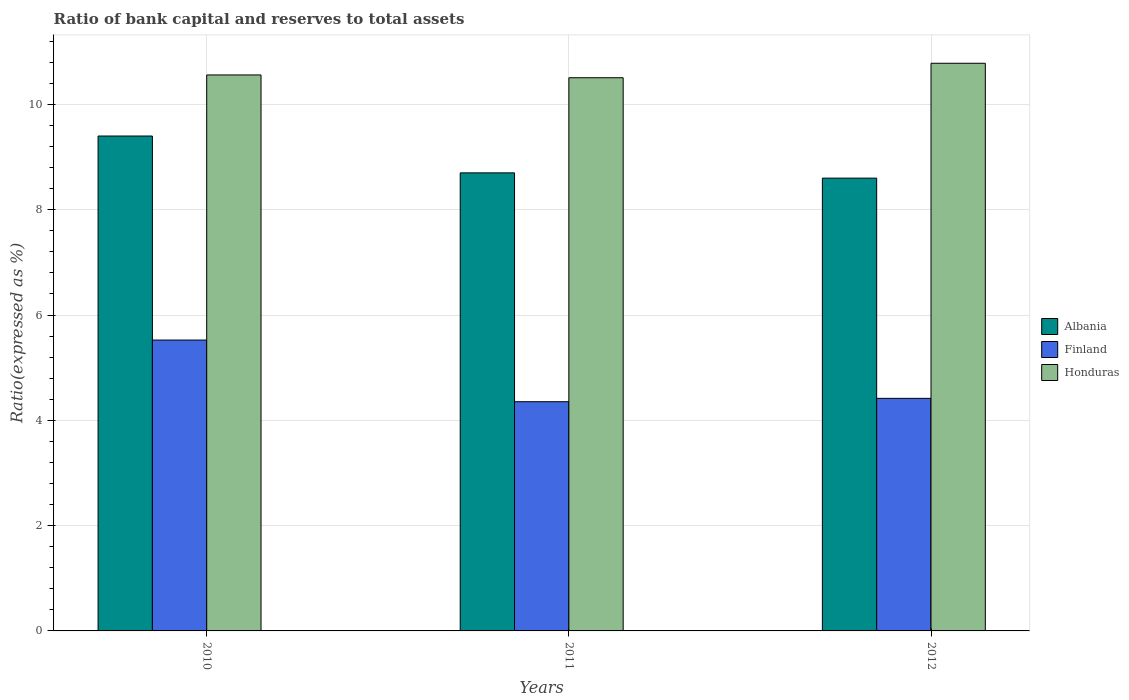How many different coloured bars are there?
Give a very brief answer. 3. How many groups of bars are there?
Give a very brief answer. 3. Are the number of bars per tick equal to the number of legend labels?
Offer a very short reply. Yes. How many bars are there on the 2nd tick from the left?
Provide a succinct answer. 3. How many bars are there on the 1st tick from the right?
Your answer should be very brief. 3. What is the label of the 3rd group of bars from the left?
Your answer should be very brief. 2012. In how many cases, is the number of bars for a given year not equal to the number of legend labels?
Offer a terse response. 0. What is the ratio of bank capital and reserves to total assets in Honduras in 2011?
Offer a very short reply. 10.51. Across all years, what is the maximum ratio of bank capital and reserves to total assets in Honduras?
Ensure brevity in your answer.  10.78. Across all years, what is the minimum ratio of bank capital and reserves to total assets in Albania?
Your answer should be compact. 8.6. In which year was the ratio of bank capital and reserves to total assets in Honduras maximum?
Give a very brief answer. 2012. In which year was the ratio of bank capital and reserves to total assets in Honduras minimum?
Your answer should be compact. 2011. What is the total ratio of bank capital and reserves to total assets in Albania in the graph?
Keep it short and to the point. 26.7. What is the difference between the ratio of bank capital and reserves to total assets in Honduras in 2011 and that in 2012?
Your answer should be very brief. -0.28. What is the difference between the ratio of bank capital and reserves to total assets in Finland in 2010 and the ratio of bank capital and reserves to total assets in Honduras in 2012?
Keep it short and to the point. -5.26. What is the average ratio of bank capital and reserves to total assets in Finland per year?
Keep it short and to the point. 4.77. In the year 2010, what is the difference between the ratio of bank capital and reserves to total assets in Finland and ratio of bank capital and reserves to total assets in Albania?
Your response must be concise. -3.88. In how many years, is the ratio of bank capital and reserves to total assets in Albania greater than 3.6 %?
Your answer should be compact. 3. What is the ratio of the ratio of bank capital and reserves to total assets in Honduras in 2011 to that in 2012?
Give a very brief answer. 0.97. What is the difference between the highest and the second highest ratio of bank capital and reserves to total assets in Albania?
Your answer should be compact. 0.7. What is the difference between the highest and the lowest ratio of bank capital and reserves to total assets in Albania?
Provide a succinct answer. 0.8. In how many years, is the ratio of bank capital and reserves to total assets in Honduras greater than the average ratio of bank capital and reserves to total assets in Honduras taken over all years?
Your answer should be compact. 1. What does the 3rd bar from the left in 2011 represents?
Ensure brevity in your answer.  Honduras. What does the 1st bar from the right in 2011 represents?
Keep it short and to the point. Honduras. How many bars are there?
Provide a succinct answer. 9. What is the difference between two consecutive major ticks on the Y-axis?
Offer a terse response. 2. Does the graph contain any zero values?
Make the answer very short. No. Does the graph contain grids?
Make the answer very short. Yes. Where does the legend appear in the graph?
Offer a terse response. Center right. How many legend labels are there?
Provide a short and direct response. 3. How are the legend labels stacked?
Provide a succinct answer. Vertical. What is the title of the graph?
Offer a terse response. Ratio of bank capital and reserves to total assets. Does "Bermuda" appear as one of the legend labels in the graph?
Ensure brevity in your answer.  No. What is the label or title of the X-axis?
Offer a terse response. Years. What is the label or title of the Y-axis?
Your response must be concise. Ratio(expressed as %). What is the Ratio(expressed as %) of Albania in 2010?
Make the answer very short. 9.4. What is the Ratio(expressed as %) of Finland in 2010?
Make the answer very short. 5.52. What is the Ratio(expressed as %) in Honduras in 2010?
Make the answer very short. 10.56. What is the Ratio(expressed as %) in Albania in 2011?
Offer a terse response. 8.7. What is the Ratio(expressed as %) of Finland in 2011?
Ensure brevity in your answer.  4.35. What is the Ratio(expressed as %) in Honduras in 2011?
Your answer should be compact. 10.51. What is the Ratio(expressed as %) in Finland in 2012?
Offer a terse response. 4.42. What is the Ratio(expressed as %) in Honduras in 2012?
Make the answer very short. 10.78. Across all years, what is the maximum Ratio(expressed as %) in Albania?
Offer a terse response. 9.4. Across all years, what is the maximum Ratio(expressed as %) of Finland?
Ensure brevity in your answer.  5.52. Across all years, what is the maximum Ratio(expressed as %) of Honduras?
Offer a very short reply. 10.78. Across all years, what is the minimum Ratio(expressed as %) of Finland?
Your answer should be compact. 4.35. Across all years, what is the minimum Ratio(expressed as %) of Honduras?
Provide a short and direct response. 10.51. What is the total Ratio(expressed as %) of Albania in the graph?
Your answer should be compact. 26.7. What is the total Ratio(expressed as %) of Finland in the graph?
Offer a terse response. 14.3. What is the total Ratio(expressed as %) of Honduras in the graph?
Your answer should be very brief. 31.85. What is the difference between the Ratio(expressed as %) of Finland in 2010 and that in 2011?
Keep it short and to the point. 1.17. What is the difference between the Ratio(expressed as %) of Honduras in 2010 and that in 2011?
Keep it short and to the point. 0.05. What is the difference between the Ratio(expressed as %) in Albania in 2010 and that in 2012?
Offer a terse response. 0.8. What is the difference between the Ratio(expressed as %) of Finland in 2010 and that in 2012?
Give a very brief answer. 1.11. What is the difference between the Ratio(expressed as %) in Honduras in 2010 and that in 2012?
Keep it short and to the point. -0.22. What is the difference between the Ratio(expressed as %) of Finland in 2011 and that in 2012?
Offer a terse response. -0.06. What is the difference between the Ratio(expressed as %) of Honduras in 2011 and that in 2012?
Your answer should be compact. -0.28. What is the difference between the Ratio(expressed as %) in Albania in 2010 and the Ratio(expressed as %) in Finland in 2011?
Offer a terse response. 5.05. What is the difference between the Ratio(expressed as %) in Albania in 2010 and the Ratio(expressed as %) in Honduras in 2011?
Offer a terse response. -1.11. What is the difference between the Ratio(expressed as %) of Finland in 2010 and the Ratio(expressed as %) of Honduras in 2011?
Your answer should be compact. -4.98. What is the difference between the Ratio(expressed as %) in Albania in 2010 and the Ratio(expressed as %) in Finland in 2012?
Make the answer very short. 4.98. What is the difference between the Ratio(expressed as %) of Albania in 2010 and the Ratio(expressed as %) of Honduras in 2012?
Ensure brevity in your answer.  -1.38. What is the difference between the Ratio(expressed as %) in Finland in 2010 and the Ratio(expressed as %) in Honduras in 2012?
Keep it short and to the point. -5.26. What is the difference between the Ratio(expressed as %) of Albania in 2011 and the Ratio(expressed as %) of Finland in 2012?
Offer a terse response. 4.28. What is the difference between the Ratio(expressed as %) of Albania in 2011 and the Ratio(expressed as %) of Honduras in 2012?
Offer a terse response. -2.08. What is the difference between the Ratio(expressed as %) in Finland in 2011 and the Ratio(expressed as %) in Honduras in 2012?
Ensure brevity in your answer.  -6.43. What is the average Ratio(expressed as %) in Finland per year?
Your response must be concise. 4.77. What is the average Ratio(expressed as %) of Honduras per year?
Make the answer very short. 10.62. In the year 2010, what is the difference between the Ratio(expressed as %) of Albania and Ratio(expressed as %) of Finland?
Your answer should be very brief. 3.88. In the year 2010, what is the difference between the Ratio(expressed as %) in Albania and Ratio(expressed as %) in Honduras?
Provide a short and direct response. -1.16. In the year 2010, what is the difference between the Ratio(expressed as %) of Finland and Ratio(expressed as %) of Honduras?
Your answer should be compact. -5.04. In the year 2011, what is the difference between the Ratio(expressed as %) of Albania and Ratio(expressed as %) of Finland?
Provide a succinct answer. 4.35. In the year 2011, what is the difference between the Ratio(expressed as %) in Albania and Ratio(expressed as %) in Honduras?
Offer a terse response. -1.81. In the year 2011, what is the difference between the Ratio(expressed as %) of Finland and Ratio(expressed as %) of Honduras?
Your answer should be compact. -6.15. In the year 2012, what is the difference between the Ratio(expressed as %) of Albania and Ratio(expressed as %) of Finland?
Your response must be concise. 4.18. In the year 2012, what is the difference between the Ratio(expressed as %) of Albania and Ratio(expressed as %) of Honduras?
Give a very brief answer. -2.18. In the year 2012, what is the difference between the Ratio(expressed as %) of Finland and Ratio(expressed as %) of Honduras?
Make the answer very short. -6.36. What is the ratio of the Ratio(expressed as %) of Albania in 2010 to that in 2011?
Make the answer very short. 1.08. What is the ratio of the Ratio(expressed as %) in Finland in 2010 to that in 2011?
Make the answer very short. 1.27. What is the ratio of the Ratio(expressed as %) in Albania in 2010 to that in 2012?
Give a very brief answer. 1.09. What is the ratio of the Ratio(expressed as %) in Finland in 2010 to that in 2012?
Provide a succinct answer. 1.25. What is the ratio of the Ratio(expressed as %) in Honduras in 2010 to that in 2012?
Keep it short and to the point. 0.98. What is the ratio of the Ratio(expressed as %) of Albania in 2011 to that in 2012?
Give a very brief answer. 1.01. What is the ratio of the Ratio(expressed as %) of Finland in 2011 to that in 2012?
Keep it short and to the point. 0.99. What is the ratio of the Ratio(expressed as %) of Honduras in 2011 to that in 2012?
Offer a very short reply. 0.97. What is the difference between the highest and the second highest Ratio(expressed as %) of Albania?
Give a very brief answer. 0.7. What is the difference between the highest and the second highest Ratio(expressed as %) of Finland?
Give a very brief answer. 1.11. What is the difference between the highest and the second highest Ratio(expressed as %) in Honduras?
Make the answer very short. 0.22. What is the difference between the highest and the lowest Ratio(expressed as %) of Finland?
Provide a succinct answer. 1.17. What is the difference between the highest and the lowest Ratio(expressed as %) of Honduras?
Your answer should be compact. 0.28. 